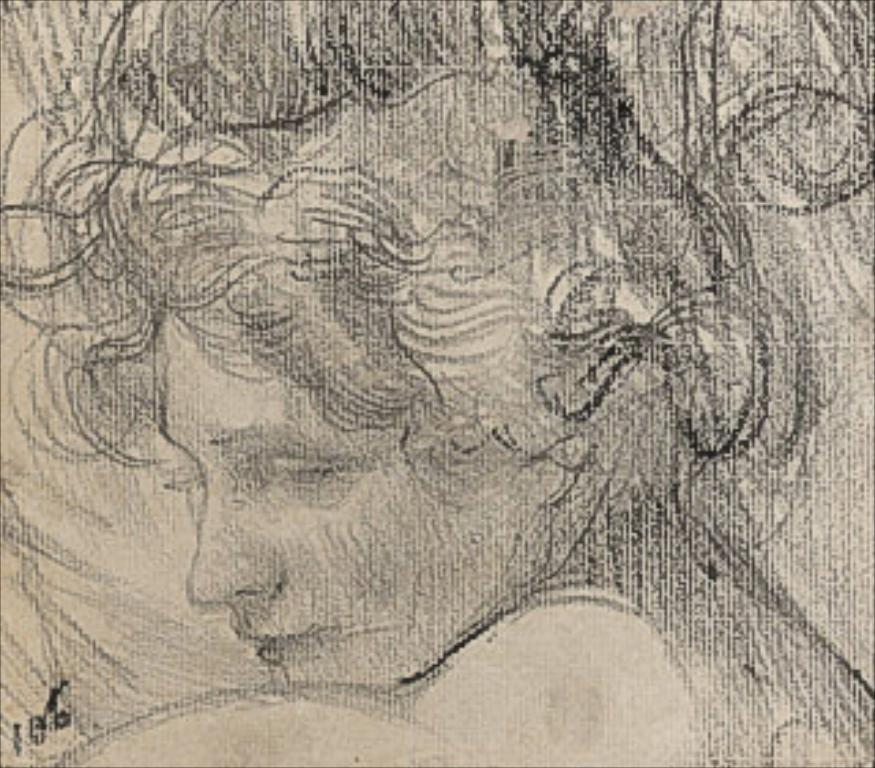What is depicted on the paper in the image? There is a drawing of a person on the paper. What colors are used in the image? The image is in black and cream color. What type of dog is shown serving the person in the image? There is no dog or person serving in the image; it only features a drawing of a person on the paper. 